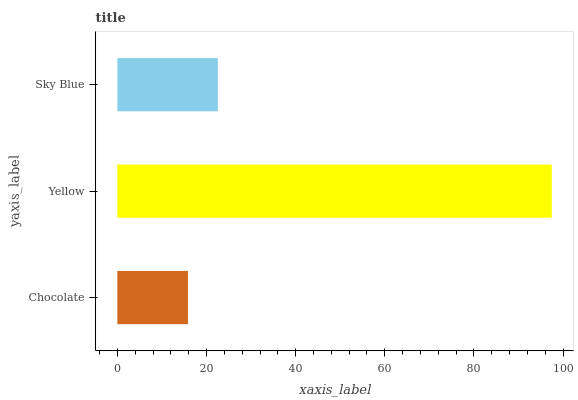Is Chocolate the minimum?
Answer yes or no. Yes. Is Yellow the maximum?
Answer yes or no. Yes. Is Sky Blue the minimum?
Answer yes or no. No. Is Sky Blue the maximum?
Answer yes or no. No. Is Yellow greater than Sky Blue?
Answer yes or no. Yes. Is Sky Blue less than Yellow?
Answer yes or no. Yes. Is Sky Blue greater than Yellow?
Answer yes or no. No. Is Yellow less than Sky Blue?
Answer yes or no. No. Is Sky Blue the high median?
Answer yes or no. Yes. Is Sky Blue the low median?
Answer yes or no. Yes. Is Yellow the high median?
Answer yes or no. No. Is Yellow the low median?
Answer yes or no. No. 